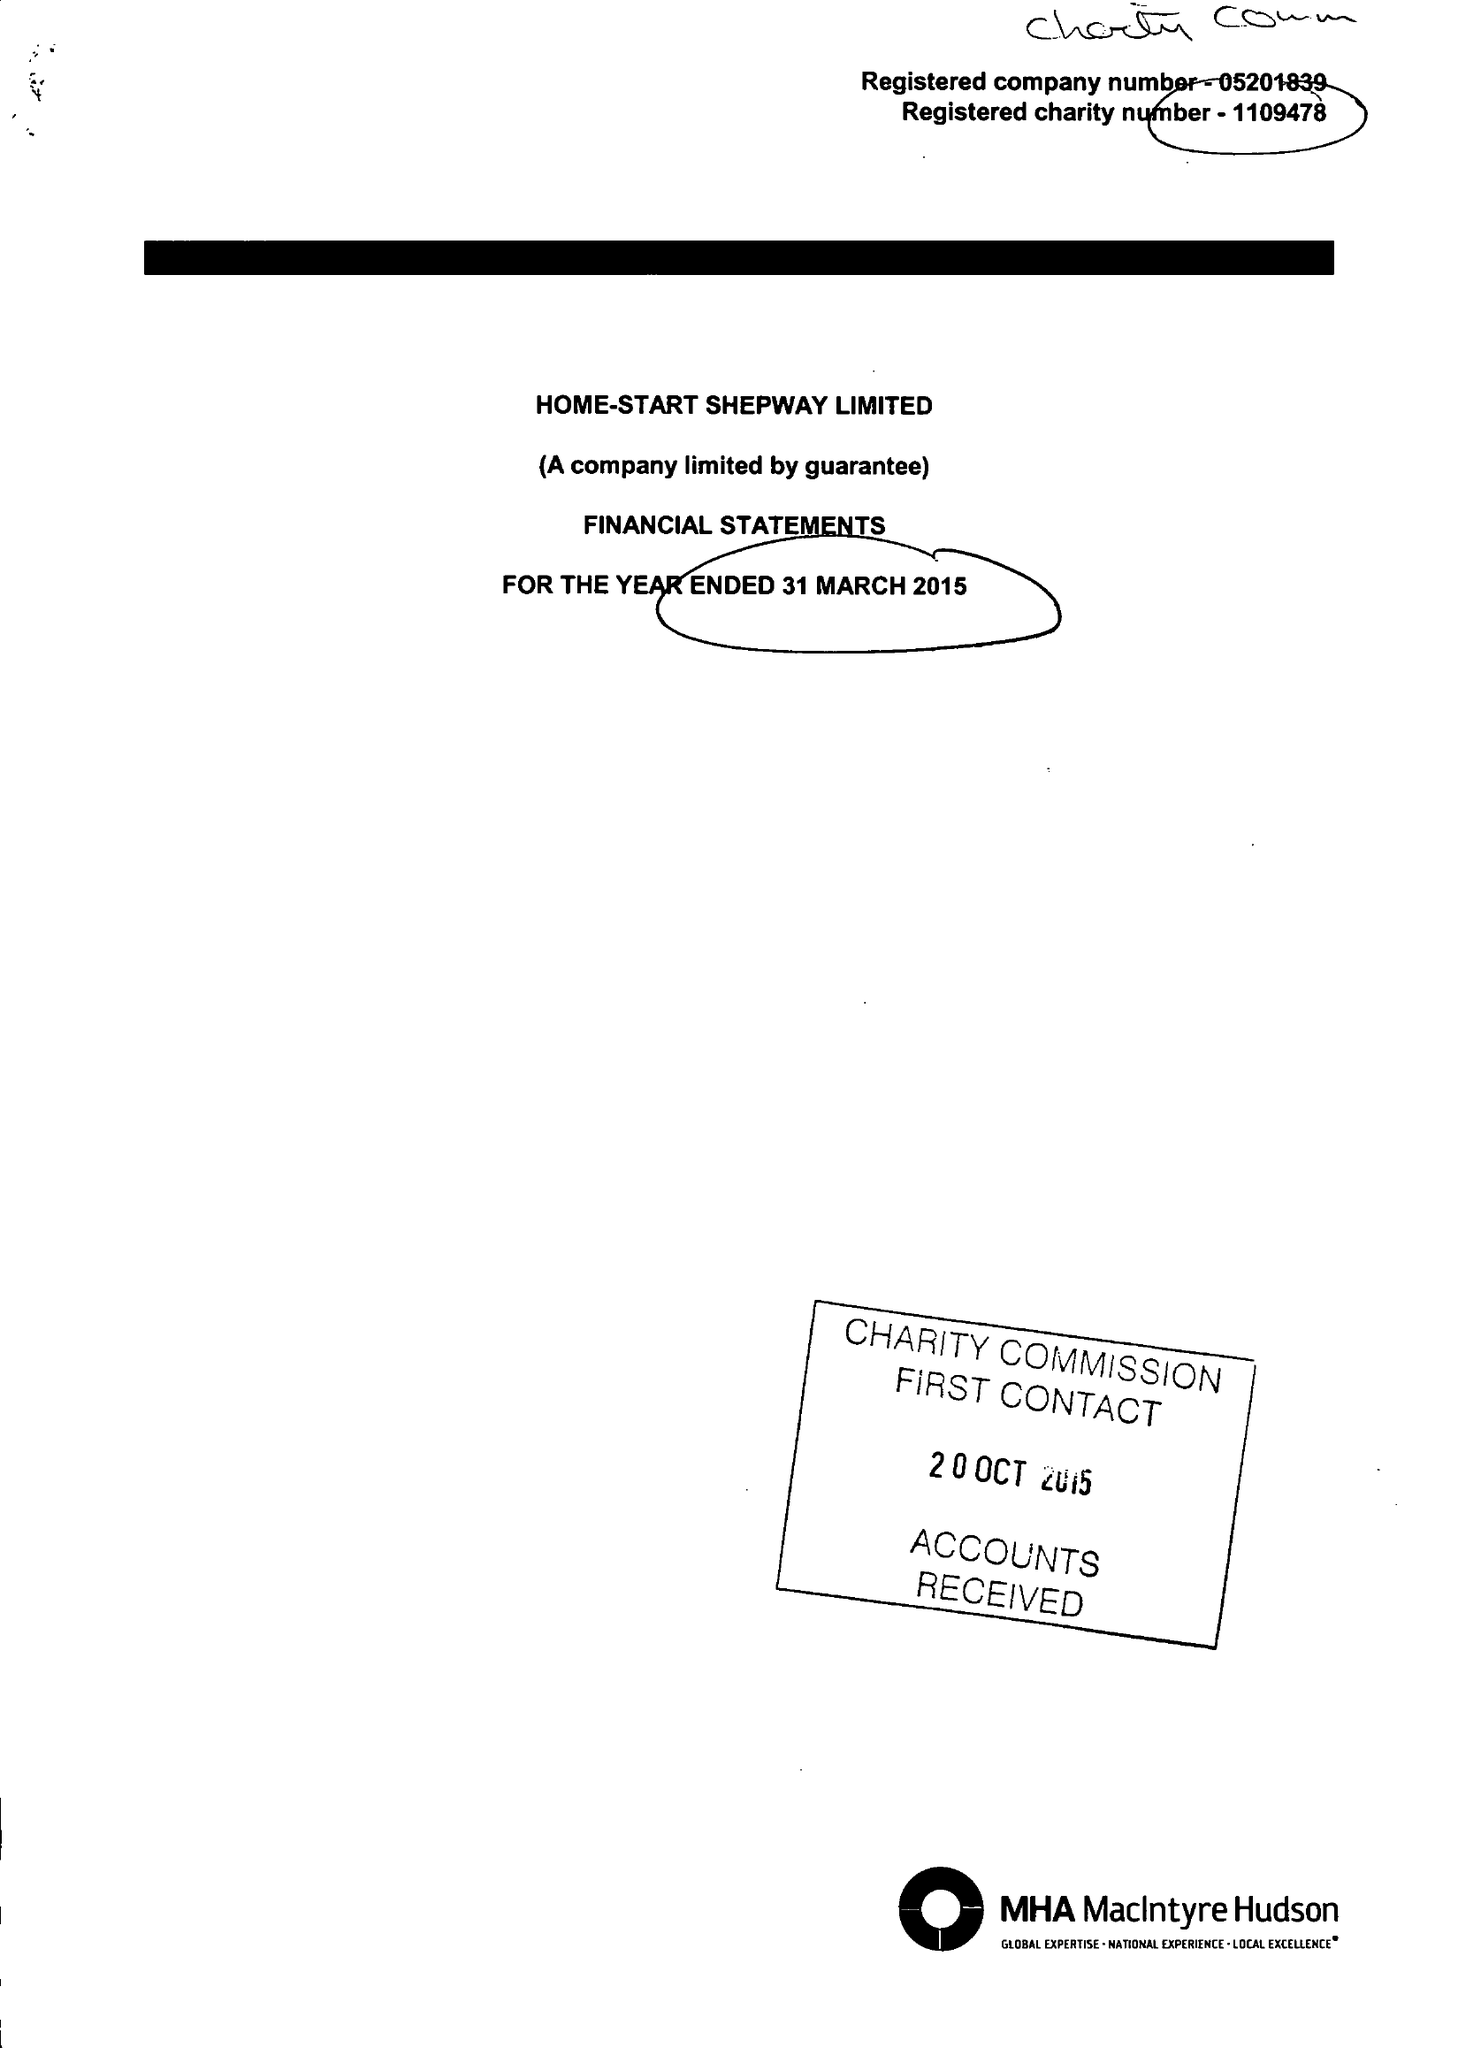What is the value for the spending_annually_in_british_pounds?
Answer the question using a single word or phrase. 318033.00 